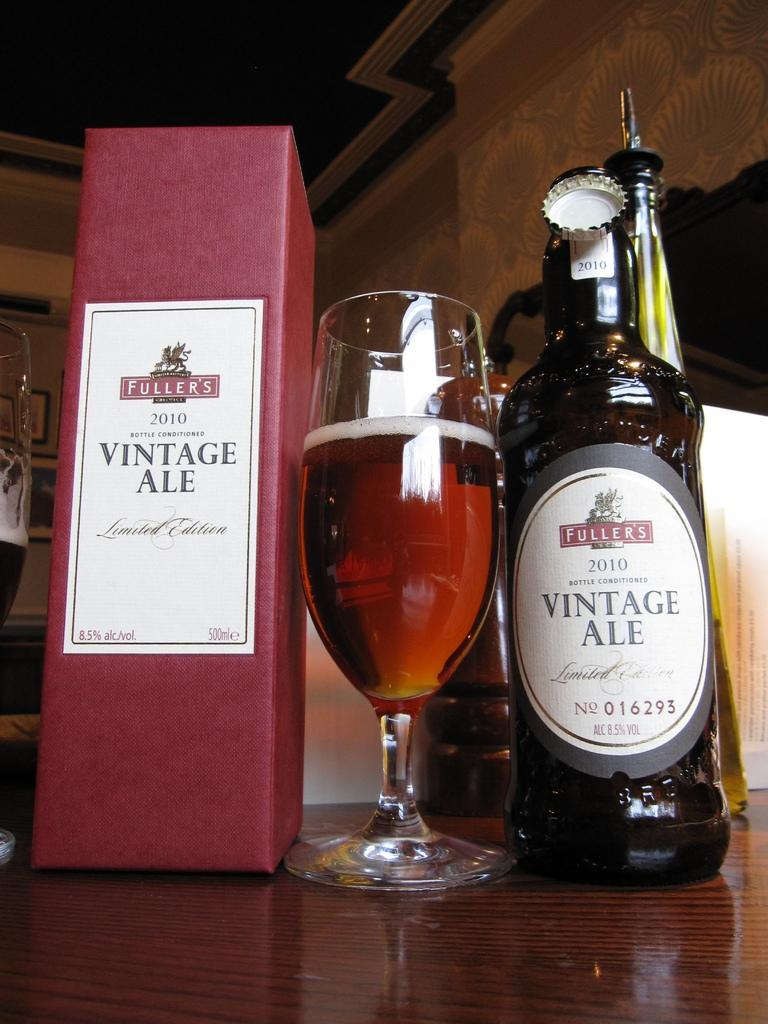<image>
Provide a brief description of the given image. A bottle of Fuller's Vintage Ale is on a table next to a glass and the box. 